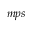Convert formula to latex. <formula><loc_0><loc_0><loc_500><loc_500>{ _ { m p s } }</formula> 